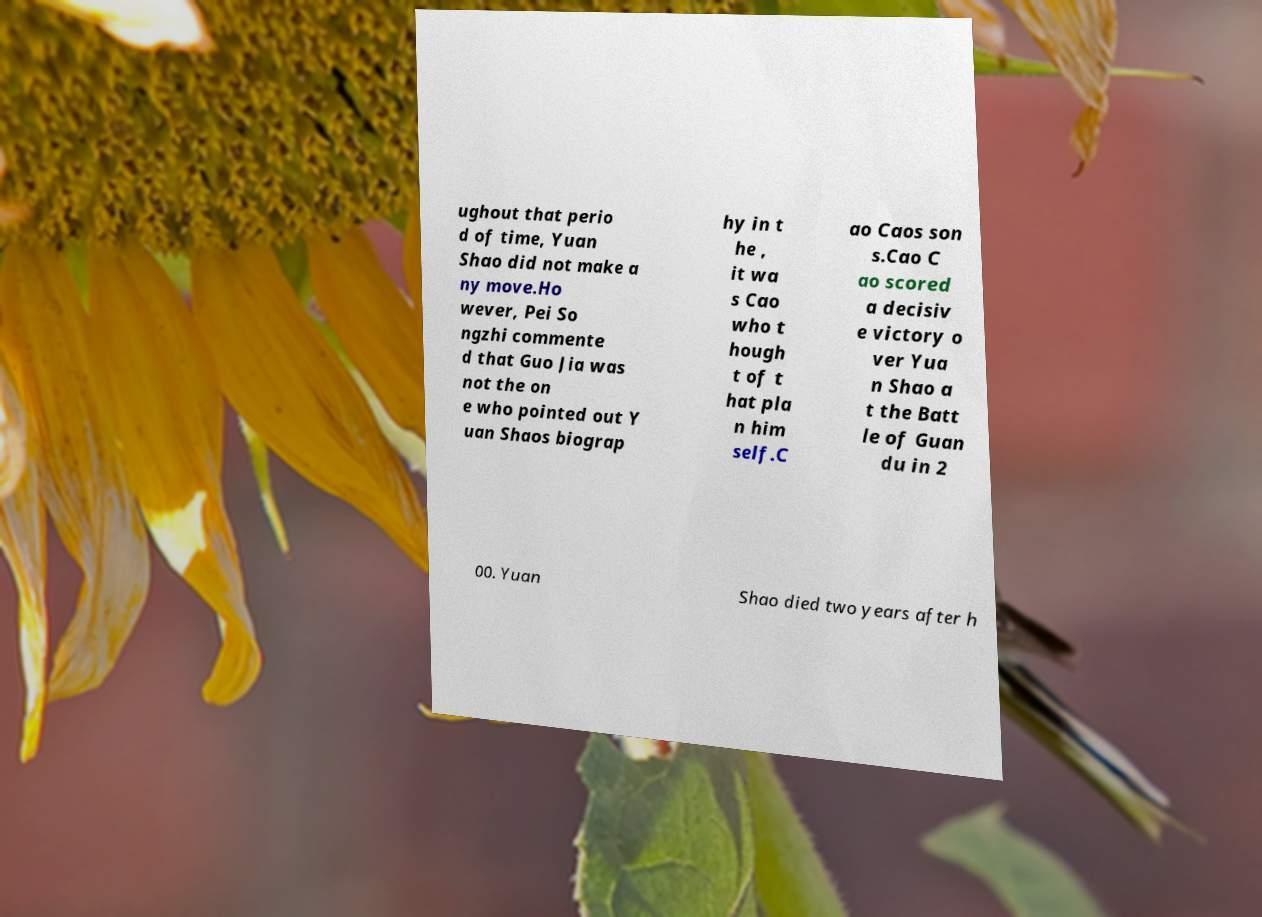Please read and relay the text visible in this image. What does it say? ughout that perio d of time, Yuan Shao did not make a ny move.Ho wever, Pei So ngzhi commente d that Guo Jia was not the on e who pointed out Y uan Shaos biograp hy in t he , it wa s Cao who t hough t of t hat pla n him self.C ao Caos son s.Cao C ao scored a decisiv e victory o ver Yua n Shao a t the Batt le of Guan du in 2 00. Yuan Shao died two years after h 